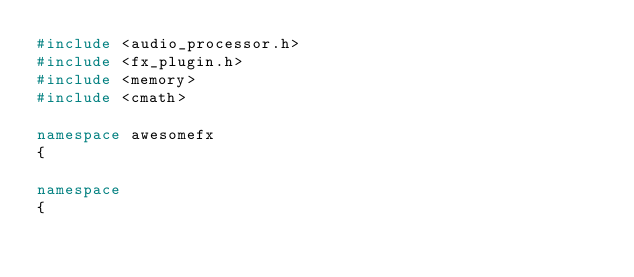<code> <loc_0><loc_0><loc_500><loc_500><_C++_>#include <audio_processor.h>
#include <fx_plugin.h>
#include <memory>
#include <cmath>

namespace awesomefx
{

namespace
{</code> 